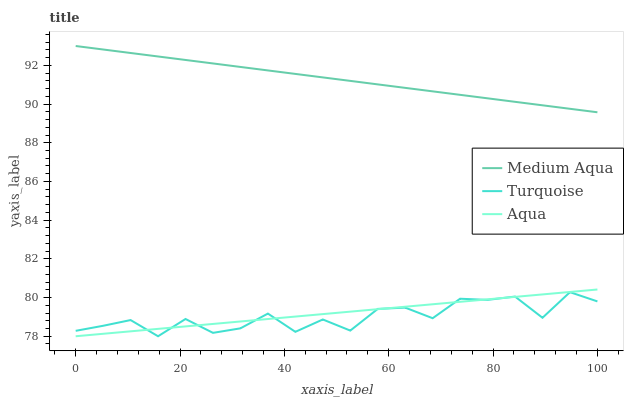Does Medium Aqua have the minimum area under the curve?
Answer yes or no. No. Does Turquoise have the maximum area under the curve?
Answer yes or no. No. Is Medium Aqua the smoothest?
Answer yes or no. No. Is Medium Aqua the roughest?
Answer yes or no. No. Does Medium Aqua have the lowest value?
Answer yes or no. No. Does Turquoise have the highest value?
Answer yes or no. No. Is Turquoise less than Medium Aqua?
Answer yes or no. Yes. Is Medium Aqua greater than Aqua?
Answer yes or no. Yes. Does Turquoise intersect Medium Aqua?
Answer yes or no. No. 